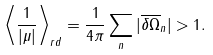Convert formula to latex. <formula><loc_0><loc_0><loc_500><loc_500>\left \langle \frac { 1 } { | \mu | } \right \rangle _ { r d } = \frac { 1 } { 4 \pi } \sum _ { n } | \overline { \delta \Omega } _ { n } | > 1 .</formula> 